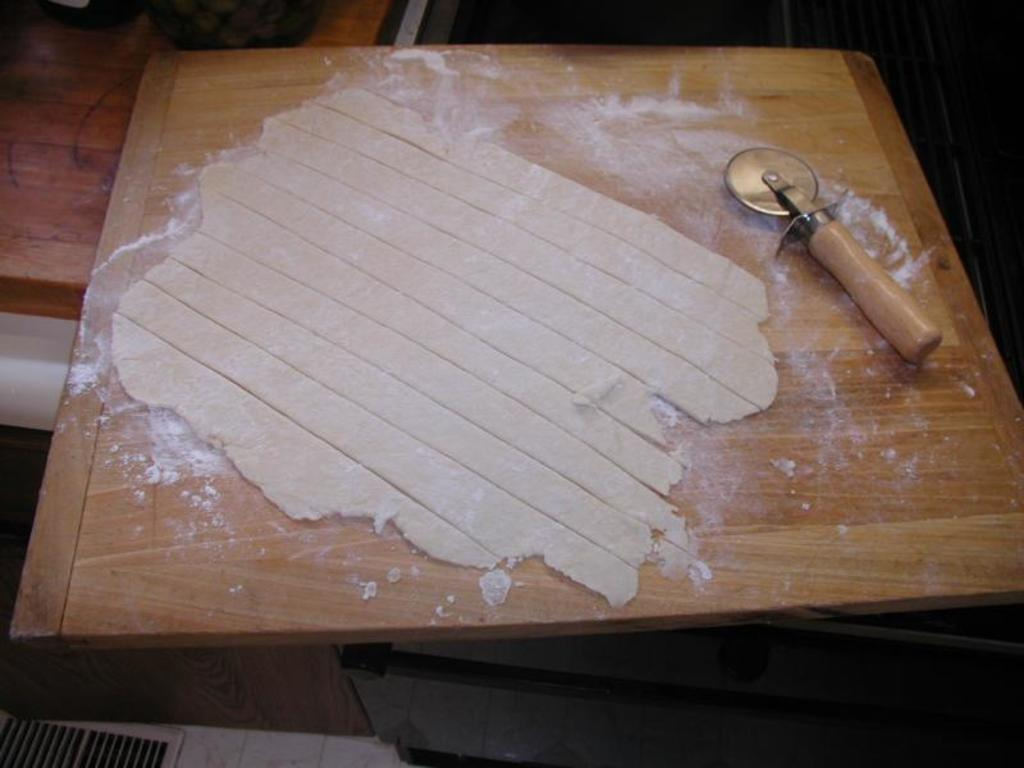What is the main subject in the center of the image? There is dough in the center of the image. What type of surface is the dough placed on? The dough is on a wooden surface. What else can be seen on the wooden surface? There is a making object on the wooden surface. What type of polish is being applied to the desk in the image? There is no desk or polish present in the image; it features dough on a wooden surface with a making object. 